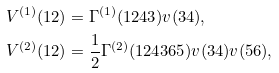<formula> <loc_0><loc_0><loc_500><loc_500>V ^ { ( 1 ) } ( 1 2 ) & = \Gamma ^ { ( 1 ) } ( 1 2 4 3 ) v ( 3 4 ) , \\ V ^ { ( 2 ) } ( 1 2 ) & = \frac { 1 } { 2 } \Gamma ^ { ( 2 ) } ( 1 2 4 3 6 5 ) v ( 3 4 ) v ( 5 6 ) ,</formula> 